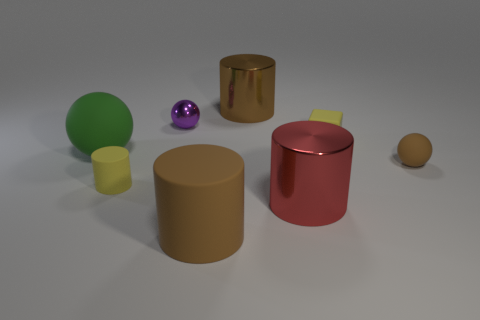Which object in this image looks the most reflective? The small purple sphere in the middle of the image appears to be the most reflective. Its surface catches the light, reflecting the surroundings with a shiny gloss. 